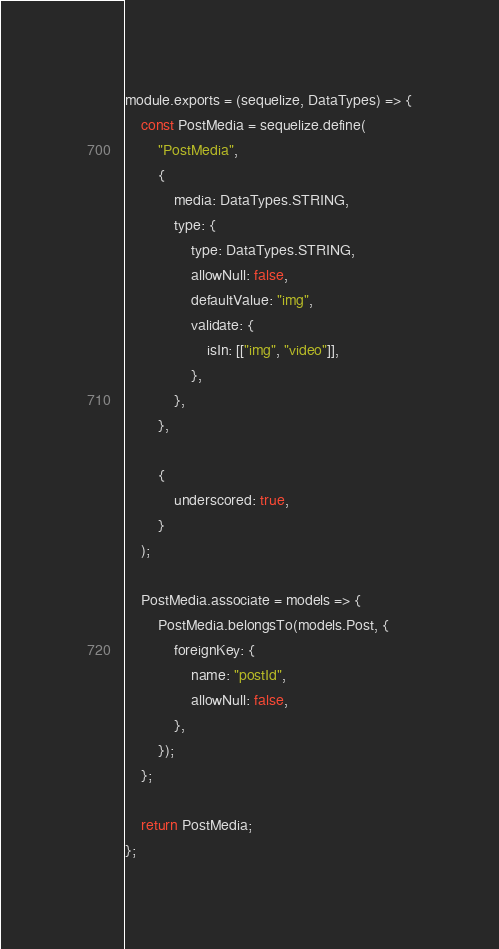<code> <loc_0><loc_0><loc_500><loc_500><_JavaScript_>module.exports = (sequelize, DataTypes) => {
	const PostMedia = sequelize.define(
		"PostMedia",
		{
			media: DataTypes.STRING,
			type: {
				type: DataTypes.STRING,
				allowNull: false,
				defaultValue: "img",
				validate: {
					isIn: [["img", "video"]],
				},
			},
		},

		{
			underscored: true,
		}
	);

	PostMedia.associate = models => {
		PostMedia.belongsTo(models.Post, {
			foreignKey: {
				name: "postId",
				allowNull: false,
			},
		});
	};

	return PostMedia;
};
</code> 